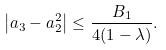Convert formula to latex. <formula><loc_0><loc_0><loc_500><loc_500>\left | a _ { 3 } - a _ { 2 } ^ { 2 } \right | \leq \frac { B _ { 1 } } { 4 ( 1 - \lambda ) } .</formula> 